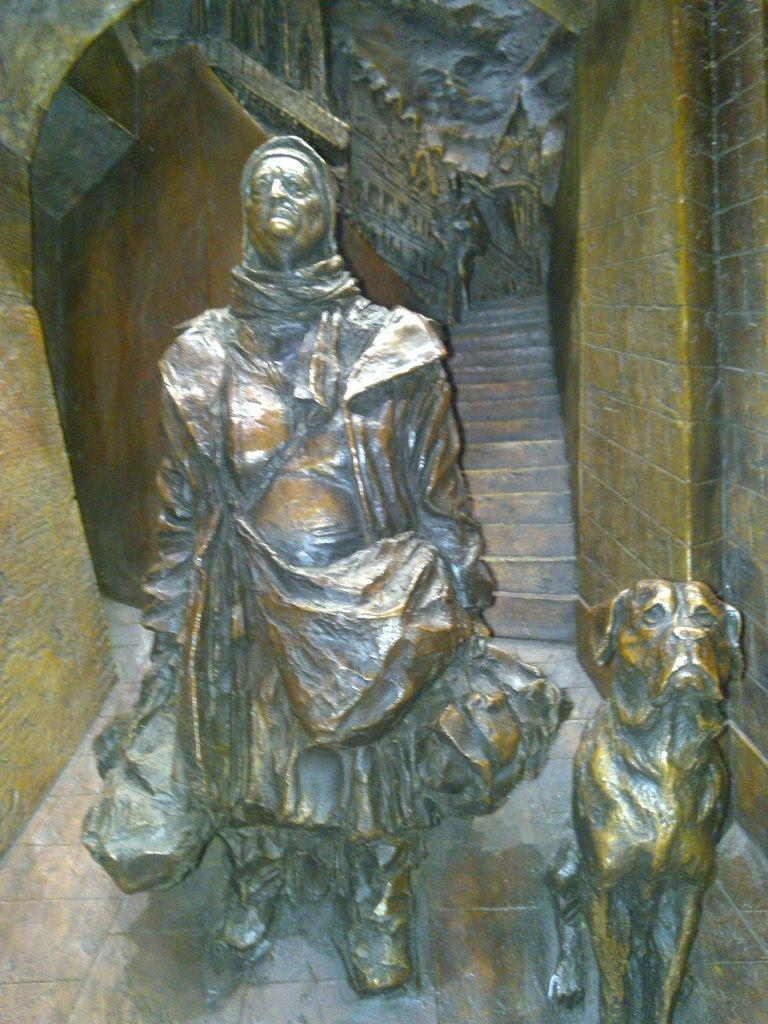What types of statues are present in the image? There is a statue of a person and a statue of an animal in the image. What can be seen in the background of the image? There are steps and walls in the background of the image. What type of support is the statue using to hold up the throne in the image? There is no throne present in the image, and therefore no support is needed for it. 